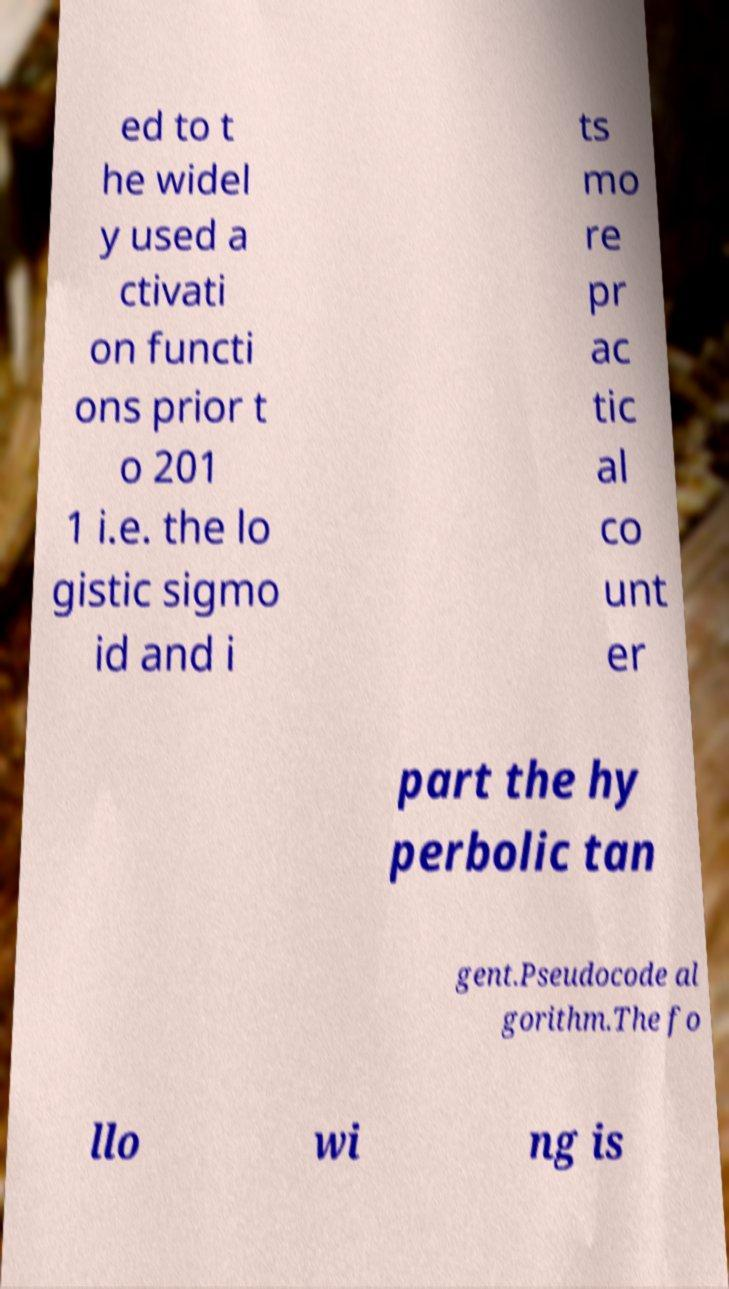What messages or text are displayed in this image? I need them in a readable, typed format. ed to t he widel y used a ctivati on functi ons prior t o 201 1 i.e. the lo gistic sigmo id and i ts mo re pr ac tic al co unt er part the hy perbolic tan gent.Pseudocode al gorithm.The fo llo wi ng is 